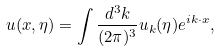<formula> <loc_0><loc_0><loc_500><loc_500>u ( { x } , \eta ) = \int \frac { d ^ { 3 } { k } } { ( 2 \pi ) ^ { 3 } } u _ { k } ( \eta ) e ^ { i { k } \cdot { x } } ,</formula> 